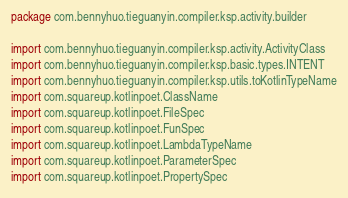Convert code to text. <code><loc_0><loc_0><loc_500><loc_500><_Kotlin_>package com.bennyhuo.tieguanyin.compiler.ksp.activity.builder

import com.bennyhuo.tieguanyin.compiler.ksp.activity.ActivityClass
import com.bennyhuo.tieguanyin.compiler.ksp.basic.types.INTENT
import com.bennyhuo.tieguanyin.compiler.ksp.utils.toKotlinTypeName
import com.squareup.kotlinpoet.ClassName
import com.squareup.kotlinpoet.FileSpec
import com.squareup.kotlinpoet.FunSpec
import com.squareup.kotlinpoet.LambdaTypeName
import com.squareup.kotlinpoet.ParameterSpec
import com.squareup.kotlinpoet.PropertySpec</code> 